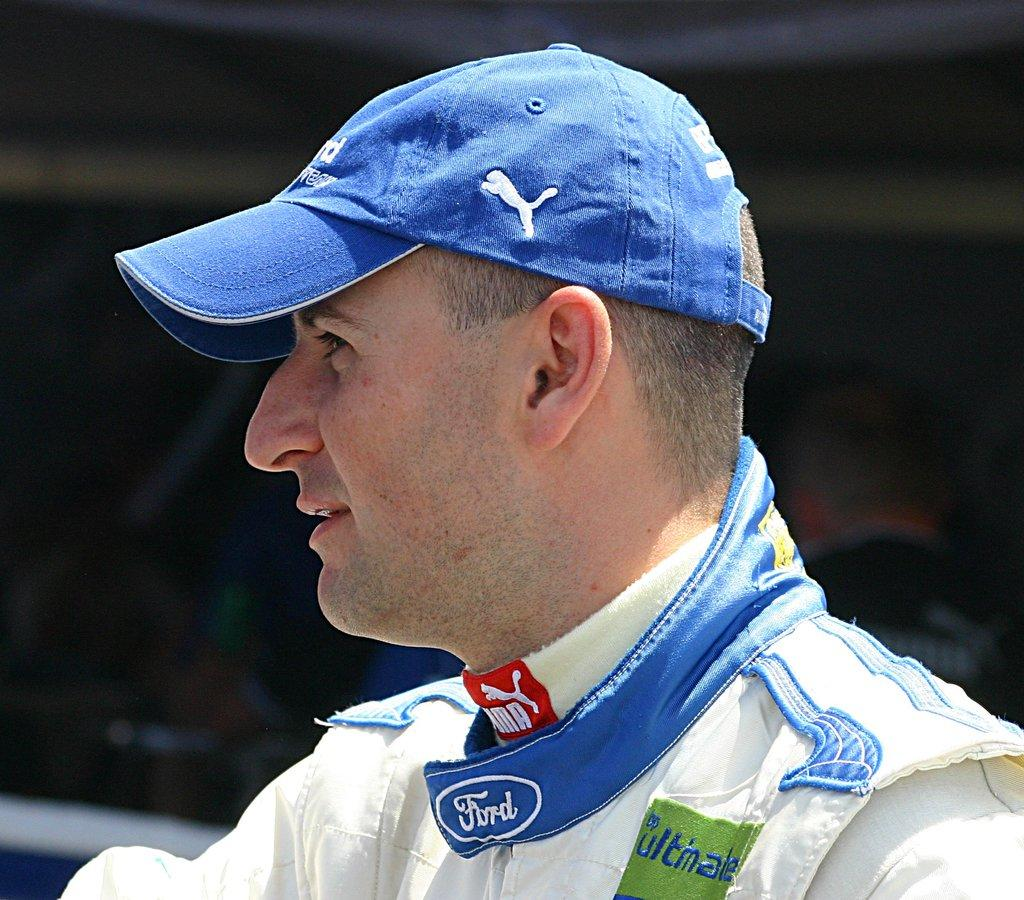Provide a one-sentence caption for the provided image. The car being advertised on the jacked is Ford. 